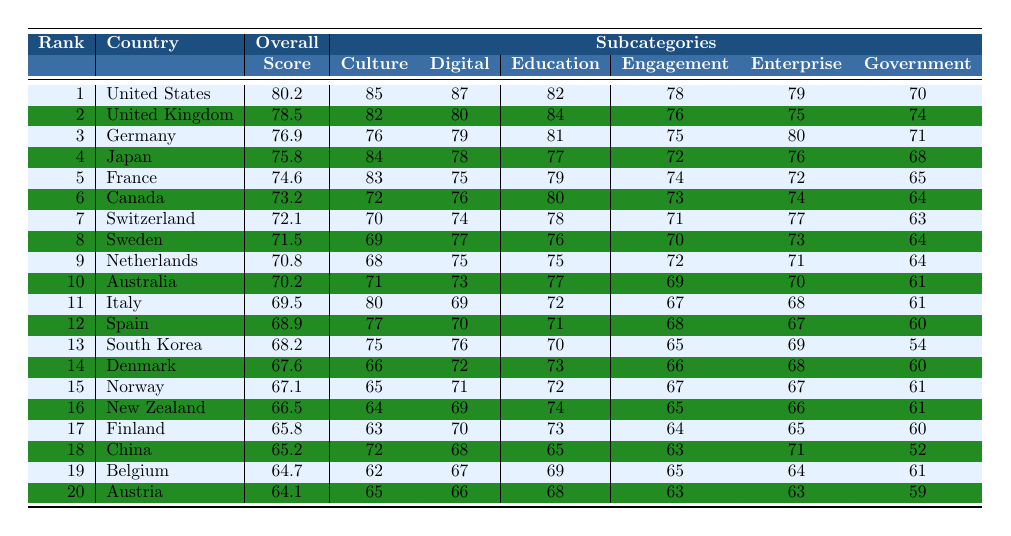What is the overall score of the United States? The table shows that the United States is ranked first, and its overall score is listed as 80.2.
Answer: 80.2 Which country has the highest score in the Education subcategory? In the table, the United States has an Education score of 82, which is the highest among all countries listed in that subcategory.
Answer: United States What is the average Overall Score of the top 5 countries? The Overall Scores of the top 5 countries are 80.2, 78.5, 76.9, 75.8, and 74.6. To find the average, we sum these scores: 80.2 + 78.5 + 76.9 + 75.8 + 74.6 = 386. The average is 386 / 5 = 77.2.
Answer: 77.2 Is Japan ranked higher than Germany in the Overall Score? Japan is ranked 4th with an Overall Score of 75.8, while Germany is ranked 3rd with an Overall Score of 76.9. Since 4th is lower than 3rd, Japan is not ranked higher than Germany.
Answer: No What is the difference between the Government scores of Finland and China? Finland has a Government score of 60 and China has a Government score of 52. The difference is calculated as 60 - 52 = 8.
Answer: 8 Which country ranks 10th, and what is its score in the Digital subcategory? According to the table, Australia ranks 10th, and its score in the Digital subcategory is listed as 73.
Answer: Australia, 73 Which subcategory score does Canada perform the worst in? In the table, Canada's lowest subcategory score is Government, with a score of 64.
Answer: Government Do any countries in the top 10 have an overall score of below 70? The table shows that no countries in the top 10 have an overall score below 70; the lowest score in the top 10 is Australia's score of 70.2.
Answer: No What is the rank and Overall Score of the country with the lowest score among the top 20? Austria, ranked 20th, has the lowest Overall Score of 64.1.
Answer: Rank 20, Score 64.1 If we sum the scores in the Culture subcategory for the top three countries, what is the total? The scores in the Culture subcategory for the top three countries are 85 (United States) + 82 (United Kingdom) + 76 (Germany), totaling 85 + 82 + 76 = 243.
Answer: 243 